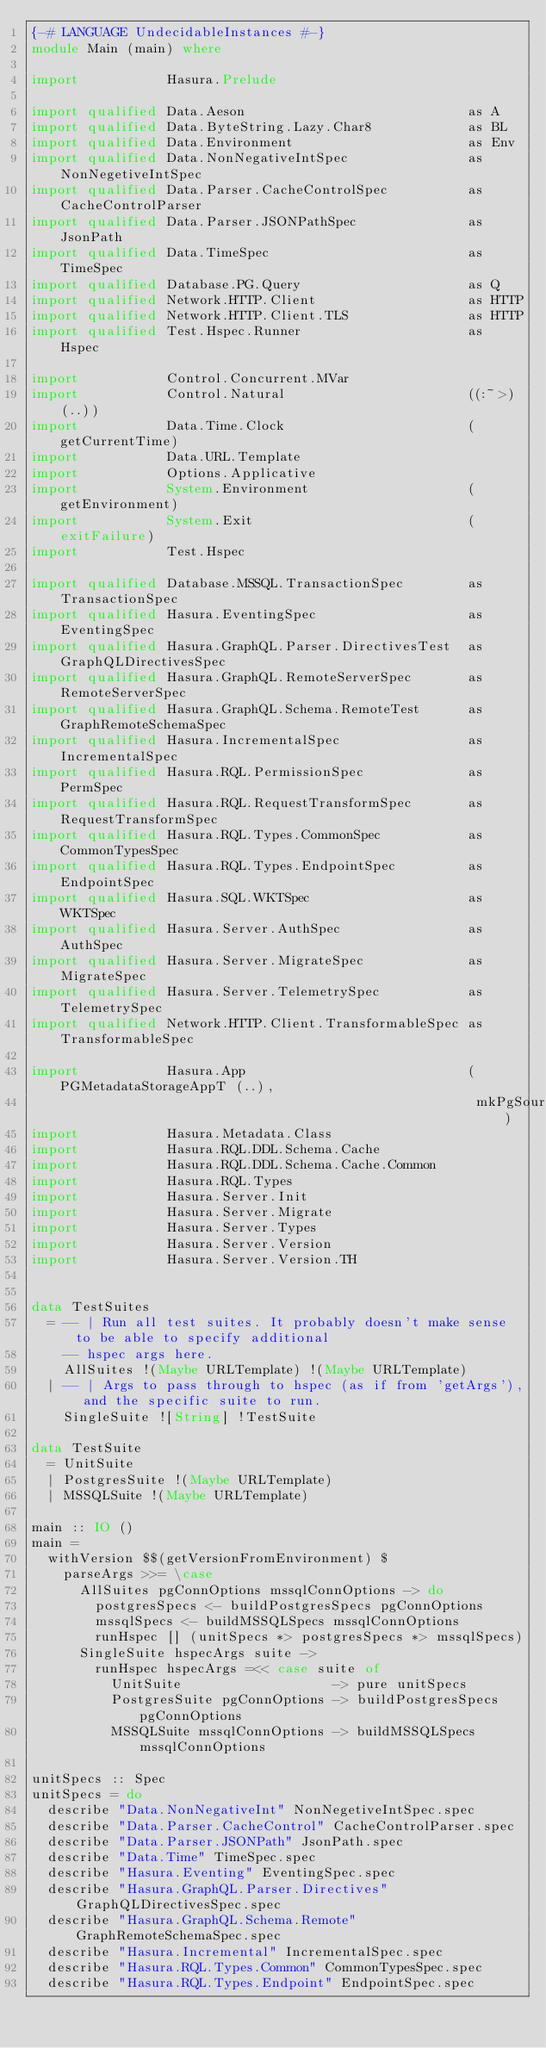<code> <loc_0><loc_0><loc_500><loc_500><_Haskell_>{-# LANGUAGE UndecidableInstances #-}
module Main (main) where

import           Hasura.Prelude

import qualified Data.Aeson                            as A
import qualified Data.ByteString.Lazy.Char8            as BL
import qualified Data.Environment                      as Env
import qualified Data.NonNegativeIntSpec               as NonNegetiveIntSpec
import qualified Data.Parser.CacheControlSpec          as CacheControlParser
import qualified Data.Parser.JSONPathSpec              as JsonPath
import qualified Data.TimeSpec                         as TimeSpec
import qualified Database.PG.Query                     as Q
import qualified Network.HTTP.Client                   as HTTP
import qualified Network.HTTP.Client.TLS               as HTTP
import qualified Test.Hspec.Runner                     as Hspec

import           Control.Concurrent.MVar
import           Control.Natural                       ((:~>) (..))
import           Data.Time.Clock                       (getCurrentTime)
import           Data.URL.Template
import           Options.Applicative
import           System.Environment                    (getEnvironment)
import           System.Exit                           (exitFailure)
import           Test.Hspec

import qualified Database.MSSQL.TransactionSpec        as TransactionSpec
import qualified Hasura.EventingSpec                   as EventingSpec
import qualified Hasura.GraphQL.Parser.DirectivesTest  as GraphQLDirectivesSpec
import qualified Hasura.GraphQL.RemoteServerSpec       as RemoteServerSpec
import qualified Hasura.GraphQL.Schema.RemoteTest      as GraphRemoteSchemaSpec
import qualified Hasura.IncrementalSpec                as IncrementalSpec
import qualified Hasura.RQL.PermissionSpec             as PermSpec
import qualified Hasura.RQL.RequestTransformSpec       as RequestTransformSpec
import qualified Hasura.RQL.Types.CommonSpec           as CommonTypesSpec
import qualified Hasura.RQL.Types.EndpointSpec         as EndpointSpec
import qualified Hasura.SQL.WKTSpec                    as WKTSpec
import qualified Hasura.Server.AuthSpec                as AuthSpec
import qualified Hasura.Server.MigrateSpec             as MigrateSpec
import qualified Hasura.Server.TelemetrySpec           as TelemetrySpec
import qualified Network.HTTP.Client.TransformableSpec as TransformableSpec

import           Hasura.App                            (PGMetadataStorageAppT (..),
                                                        mkPgSourceResolver)
import           Hasura.Metadata.Class
import           Hasura.RQL.DDL.Schema.Cache
import           Hasura.RQL.DDL.Schema.Cache.Common
import           Hasura.RQL.Types
import           Hasura.Server.Init
import           Hasura.Server.Migrate
import           Hasura.Server.Types
import           Hasura.Server.Version
import           Hasura.Server.Version.TH


data TestSuites
  = -- | Run all test suites. It probably doesn't make sense to be able to specify additional
    -- hspec args here.
    AllSuites !(Maybe URLTemplate) !(Maybe URLTemplate)
  | -- | Args to pass through to hspec (as if from 'getArgs'), and the specific suite to run.
    SingleSuite ![String] !TestSuite

data TestSuite
  = UnitSuite
  | PostgresSuite !(Maybe URLTemplate)
  | MSSQLSuite !(Maybe URLTemplate)

main :: IO ()
main =
  withVersion $$(getVersionFromEnvironment) $
    parseArgs >>= \case
      AllSuites pgConnOptions mssqlConnOptions -> do
        postgresSpecs <- buildPostgresSpecs pgConnOptions
        mssqlSpecs <- buildMSSQLSpecs mssqlConnOptions
        runHspec [] (unitSpecs *> postgresSpecs *> mssqlSpecs)
      SingleSuite hspecArgs suite ->
        runHspec hspecArgs =<< case suite of
          UnitSuite                   -> pure unitSpecs
          PostgresSuite pgConnOptions -> buildPostgresSpecs pgConnOptions
          MSSQLSuite mssqlConnOptions -> buildMSSQLSpecs mssqlConnOptions

unitSpecs :: Spec
unitSpecs = do
  describe "Data.NonNegativeInt" NonNegetiveIntSpec.spec
  describe "Data.Parser.CacheControl" CacheControlParser.spec
  describe "Data.Parser.JSONPath" JsonPath.spec
  describe "Data.Time" TimeSpec.spec
  describe "Hasura.Eventing" EventingSpec.spec
  describe "Hasura.GraphQL.Parser.Directives" GraphQLDirectivesSpec.spec
  describe "Hasura.GraphQL.Schema.Remote" GraphRemoteSchemaSpec.spec
  describe "Hasura.Incremental" IncrementalSpec.spec
  describe "Hasura.RQL.Types.Common" CommonTypesSpec.spec
  describe "Hasura.RQL.Types.Endpoint" EndpointSpec.spec</code> 